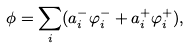Convert formula to latex. <formula><loc_0><loc_0><loc_500><loc_500>\phi = \sum _ { i } ( a _ { i } ^ { - } \varphi _ { i } ^ { - } + a _ { i } ^ { + } \varphi _ { i } ^ { + } ) ,</formula> 